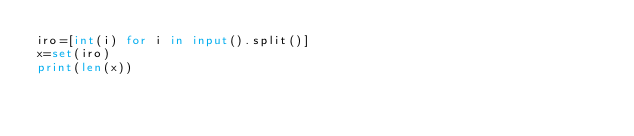<code> <loc_0><loc_0><loc_500><loc_500><_Python_>iro=[int(i) for i in input().split()]
x=set(iro)
print(len(x))</code> 